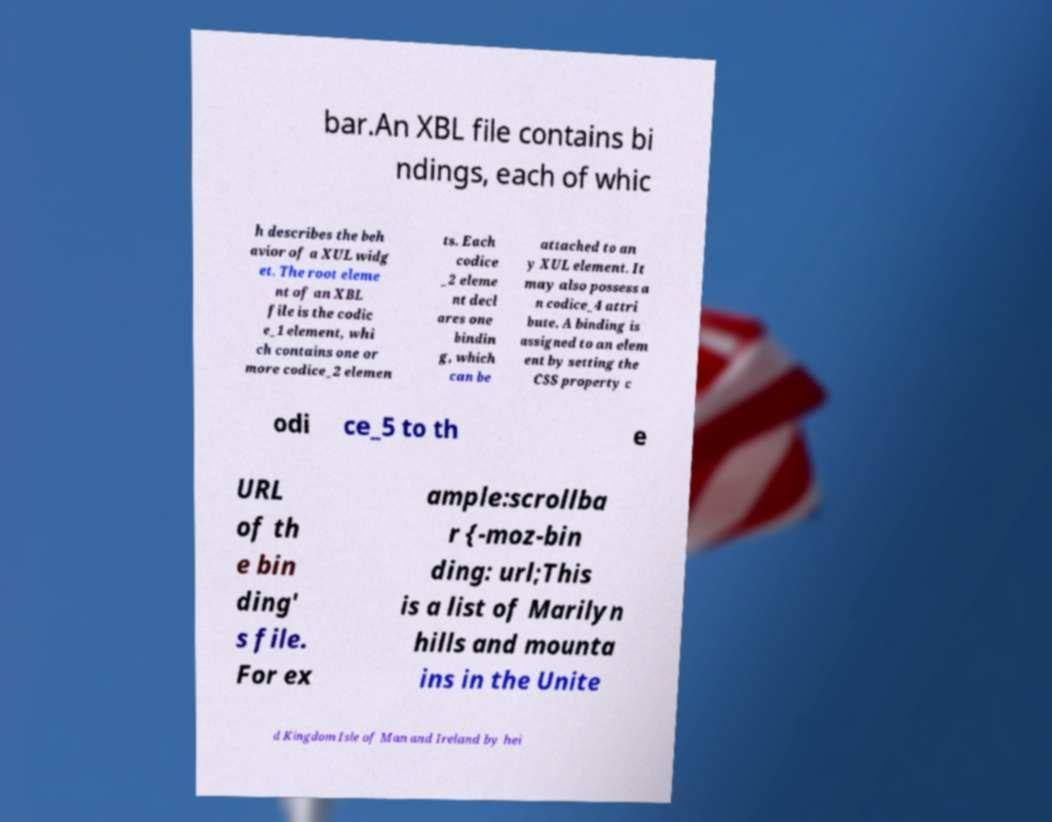Can you read and provide the text displayed in the image?This photo seems to have some interesting text. Can you extract and type it out for me? bar.An XBL file contains bi ndings, each of whic h describes the beh avior of a XUL widg et. The root eleme nt of an XBL file is the codic e_1 element, whi ch contains one or more codice_2 elemen ts. Each codice _2 eleme nt decl ares one bindin g, which can be attached to an y XUL element. It may also possess a n codice_4 attri bute. A binding is assigned to an elem ent by setting the CSS property c odi ce_5 to th e URL of th e bin ding' s file. For ex ample:scrollba r {-moz-bin ding: url;This is a list of Marilyn hills and mounta ins in the Unite d Kingdom Isle of Man and Ireland by hei 